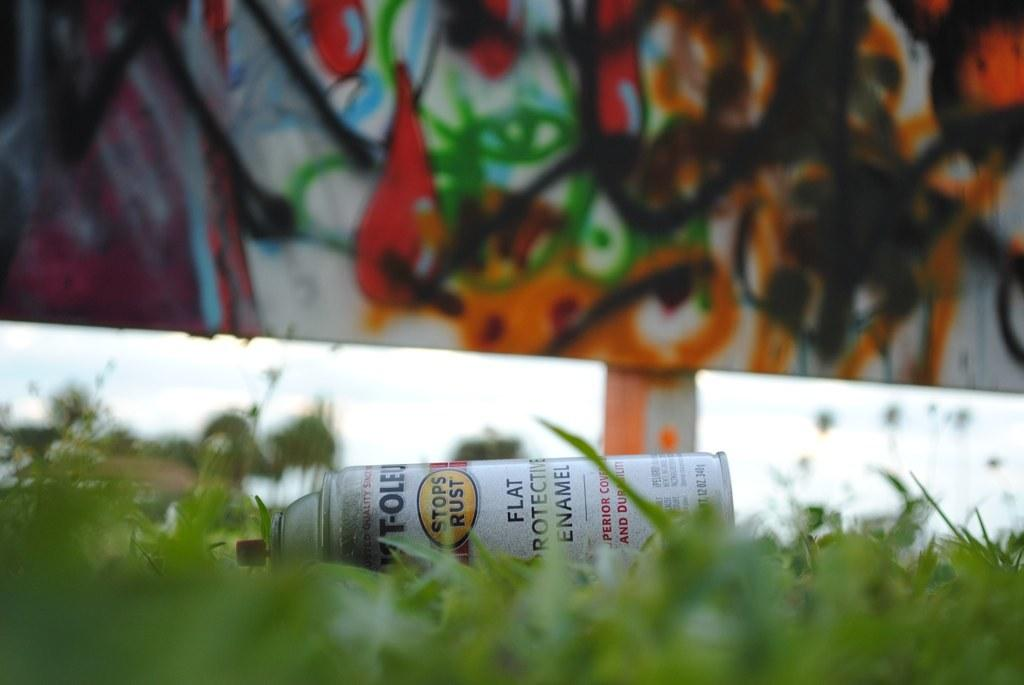<image>
Render a clear and concise summary of the photo. A spray can of flat protective enamel paint lies in the grass. 